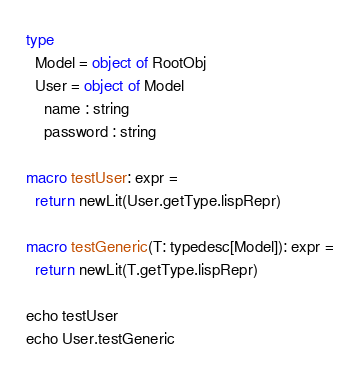<code> <loc_0><loc_0><loc_500><loc_500><_Nim_>
type
  Model = object of RootObj
  User = object of Model
    name : string
    password : string

macro testUser: expr =
  return newLit(User.getType.lispRepr)

macro testGeneric(T: typedesc[Model]): expr =
  return newLit(T.getType.lispRepr)

echo testUser
echo User.testGeneric
</code> 